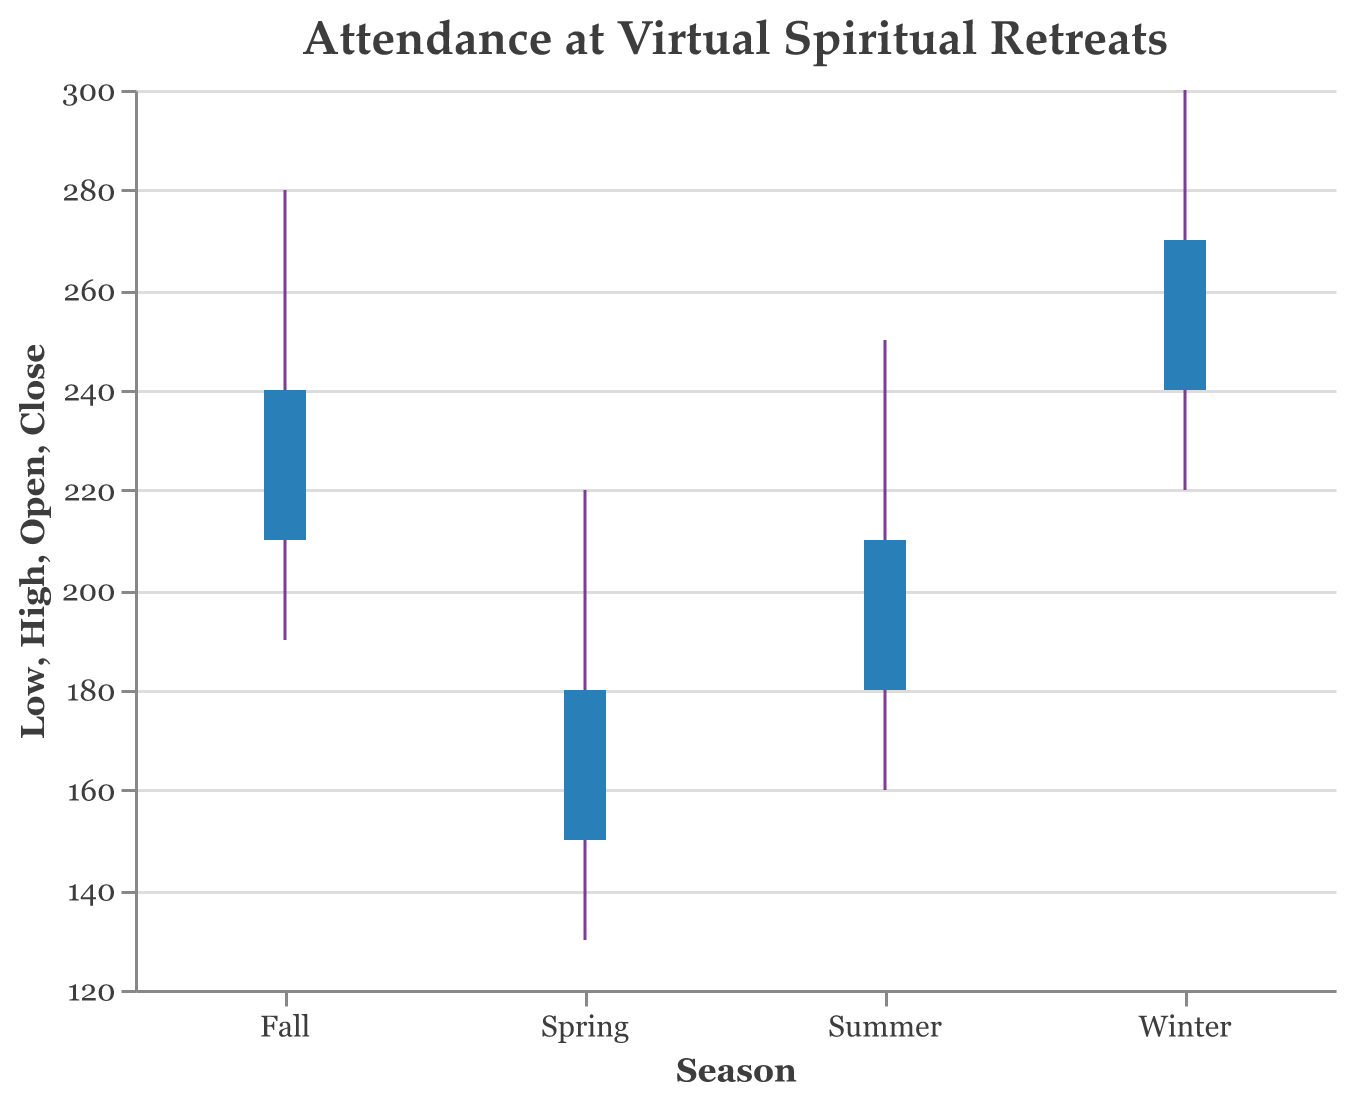What is the title of the plot? The title is usually located at the top and provides a description of what the plot represents. Here, it clearly states "Attendance at Virtual Spiritual Retreats."
Answer: Attendance at Virtual Spiritual Retreats Which season has the highest attendance level at its peak? The peak attendance level is represented by the highest point in the OHLC bar for each season. The Winter season has the highest level at 300.
Answer: Winter What is the range (difference between highest and lowest attendance) for Fall? To find the range, subtract the lowest attendance (Low) from the highest attendance (High) for Fall. The values are: High (280) - Low (190) = 90.
Answer: 90 What was the closing attendance level for Spring? The closing level for each season is shown by the top of the shorter bar within the OHLC bar for that season. For Spring, the closing attendance is 180.
Answer: 180 Which season showed the most significant increase in attendance from the open to close? To determine the season with the most significant increase, subtract the open value from the close value for each season: Spring (30), Summer (30), Fall (30), Winter (30). All seasons have the same increase of 30.
Answer: All same (30) Is the lowest attendance level higher in Winter than in Summer? Compare the lowest levels (Low) for both Winter and Summer. Winter's lowest attendance is 220, while Summer's is 160. Since 220 > 160, Winter has the higher lowest attendance.
Answer: Yes Which season's opening attendance level was the lowest? The opening levels of each season can be compared directly: Spring (150), Summer (180), Fall (210), Winter (240). The lowest among these is Spring with 150.
Answer: Spring By how much did attendance increase from Summer's low to Winter's high? Subtract Summer's lowest attendance (160) from Winter's highest attendance (300): 300 - 160 = 140.
Answer: 140 What was the midpoint (average) of the opening and closing attendance levels for Fall? Calculate the average of the open and close levels for Fall: (210 + 240) / 2 = 225.
Answer: 225 Which season has the smallest difference between its opening and closing attendance levels? Calculate the difference for each season: Spring (30), Summer (30), Fall (30), Winter (30). All seasons have the same difference of 30.
Answer: All same (30) 